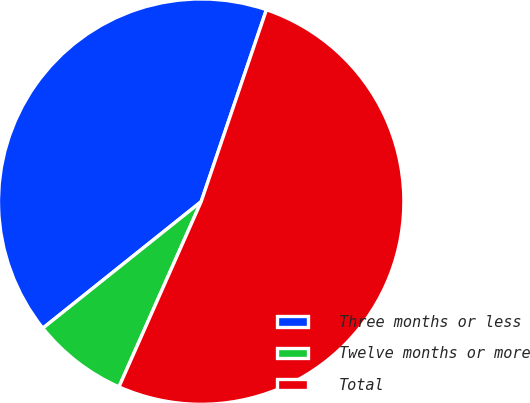<chart> <loc_0><loc_0><loc_500><loc_500><pie_chart><fcel>Three months or less<fcel>Twelve months or more<fcel>Total<nl><fcel>40.95%<fcel>7.62%<fcel>51.43%<nl></chart> 